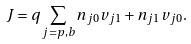Convert formula to latex. <formula><loc_0><loc_0><loc_500><loc_500>J = q \sum _ { j = p , b } n _ { j 0 } v _ { j 1 } + n _ { j 1 } v _ { j 0 } .</formula> 